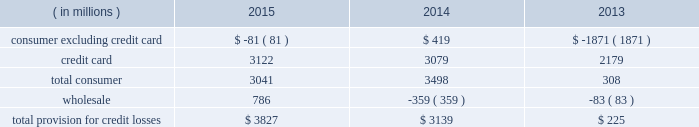Jpmorgan chase & co./2015 annual report 73 in advisory fees was driven by the combined impact of a greater share of fees for completed transactions , and growth in industry-wide fees .
The increase in equity underwriting fees was driven by higher industry-wide issuance .
The decrease in debt underwriting fees was primarily related to lower bond underwriting fees compared with the prior year , and lower loan syndication fees on lower industry-wide fees .
Principal transactions revenue increased as the prior year included a $ 1.5 billion loss related to the implementation of the funding valuation adjustment ( 201cfva 201d ) framework for over-the-counter ( 201cotc 201d ) derivatives and structured notes .
Private equity gains increased as a result of higher net gains on sales .
These increases were partially offset by lower fixed income markets revenue in cib , primarily driven by credit-related and rates products , as well as the impact of business simplification initiatives .
Lending- and deposit-related fees decreased compared with the prior year , reflecting the impact of business simplification initiatives and lower trade finance revenue in cib .
Asset management , administration and commissions revenue increased compared with the prior year , reflecting higher asset management fees driven by net client inflows and higher market levels in am and ccb .
The increase was offset partially by lower commissions and other fee revenue in ccb as a result of the exit of a non-core product in 2013 .
Securities gains decreased compared with the prior year , reflecting lower repositioning activity related to the firm 2019s investment securities portfolio .
Mortgage fees and related income decreased compared with the prior year , predominantly due to lower net production revenue driven by lower volumes due to higher mortgage interest rates , and tighter margins .
The decline in net production revenue was partially offset by a lower loss on the risk management of mortgage servicing rights ( 201cmsrs 201d ) .
Card income was relatively flat compared with the prior year , but included higher net interchange income due to growth in credit and debit card sales volume , offset by higher amortization of new account origination costs .
Other income decreased from the prior year , predominantly from the absence of two significant items recorded in corporate in 2013 : gains of $ 1.3 billion and $ 493 million from sales of visa shares and one chase manhattan plaza , respectively .
Lower valuations of seed capital investments in am and losses related to the exit of non-core portfolios in card also contributed to the decrease .
These items were partially offset by higher auto lease income as a result of growth in auto lease volume , and a benefit from a tax settlement .
Net interest income increased slightly from the prior year , predominantly reflecting higher yields on investment securities , the impact of lower interest expense from lower rates , and higher average loan balances .
The increase was partially offset by lower yields on loans due to the run-off of higher-yielding loans and new originations of lower-yielding loans , and lower average interest-earning trading asset balances .
The firm 2019s average interest-earning assets were $ 2.0 trillion , and the net interest yield on these assets , on a fte basis , was 2.18% ( 2.18 % ) , a decrease of 5 basis points from the prior year .
Provision for credit losses year ended december 31 .
2015 compared with 2014 the provision for credit losses increased from the prior year as a result of an increase in the wholesale provision , largely reflecting the impact of downgrades in the oil & gas portfolio .
The increase was partially offset by a decrease in the consumer provision , reflecting lower net charge-offs due to continued discipline in credit underwriting , as well as improvement in the economy driven by increasing home prices and lower unemployment levels .
The increase was partially offset by a lower reduction in the allowance for loan losses .
For a more detailed discussion of the credit portfolio and the allowance for credit losses , see the segment discussions of ccb on pages 85 201393 , cb on pages 99 2013101 , and the allowance for credit losses on pages 130 2013132 .
2014 compared with 2013 the provision for credit losses increased by $ 2.9 billion from the prior year as result of a lower benefit from reductions in the consumer allowance for loan losses , partially offset by lower net charge-offs .
The consumer allowance reduction in 2014 was primarily related to the consumer , excluding credit card , portfolio and reflected the continued improvement in home prices and delinquencies in the residential real estate portfolio .
The wholesale provision reflected a continued favorable credit environment. .
How much of the provision was for non-consumer credit losses? 
Computations: (786 / 3827)
Answer: 0.20538. Jpmorgan chase & co./2015 annual report 73 in advisory fees was driven by the combined impact of a greater share of fees for completed transactions , and growth in industry-wide fees .
The increase in equity underwriting fees was driven by higher industry-wide issuance .
The decrease in debt underwriting fees was primarily related to lower bond underwriting fees compared with the prior year , and lower loan syndication fees on lower industry-wide fees .
Principal transactions revenue increased as the prior year included a $ 1.5 billion loss related to the implementation of the funding valuation adjustment ( 201cfva 201d ) framework for over-the-counter ( 201cotc 201d ) derivatives and structured notes .
Private equity gains increased as a result of higher net gains on sales .
These increases were partially offset by lower fixed income markets revenue in cib , primarily driven by credit-related and rates products , as well as the impact of business simplification initiatives .
Lending- and deposit-related fees decreased compared with the prior year , reflecting the impact of business simplification initiatives and lower trade finance revenue in cib .
Asset management , administration and commissions revenue increased compared with the prior year , reflecting higher asset management fees driven by net client inflows and higher market levels in am and ccb .
The increase was offset partially by lower commissions and other fee revenue in ccb as a result of the exit of a non-core product in 2013 .
Securities gains decreased compared with the prior year , reflecting lower repositioning activity related to the firm 2019s investment securities portfolio .
Mortgage fees and related income decreased compared with the prior year , predominantly due to lower net production revenue driven by lower volumes due to higher mortgage interest rates , and tighter margins .
The decline in net production revenue was partially offset by a lower loss on the risk management of mortgage servicing rights ( 201cmsrs 201d ) .
Card income was relatively flat compared with the prior year , but included higher net interchange income due to growth in credit and debit card sales volume , offset by higher amortization of new account origination costs .
Other income decreased from the prior year , predominantly from the absence of two significant items recorded in corporate in 2013 : gains of $ 1.3 billion and $ 493 million from sales of visa shares and one chase manhattan plaza , respectively .
Lower valuations of seed capital investments in am and losses related to the exit of non-core portfolios in card also contributed to the decrease .
These items were partially offset by higher auto lease income as a result of growth in auto lease volume , and a benefit from a tax settlement .
Net interest income increased slightly from the prior year , predominantly reflecting higher yields on investment securities , the impact of lower interest expense from lower rates , and higher average loan balances .
The increase was partially offset by lower yields on loans due to the run-off of higher-yielding loans and new originations of lower-yielding loans , and lower average interest-earning trading asset balances .
The firm 2019s average interest-earning assets were $ 2.0 trillion , and the net interest yield on these assets , on a fte basis , was 2.18% ( 2.18 % ) , a decrease of 5 basis points from the prior year .
Provision for credit losses year ended december 31 .
2015 compared with 2014 the provision for credit losses increased from the prior year as a result of an increase in the wholesale provision , largely reflecting the impact of downgrades in the oil & gas portfolio .
The increase was partially offset by a decrease in the consumer provision , reflecting lower net charge-offs due to continued discipline in credit underwriting , as well as improvement in the economy driven by increasing home prices and lower unemployment levels .
The increase was partially offset by a lower reduction in the allowance for loan losses .
For a more detailed discussion of the credit portfolio and the allowance for credit losses , see the segment discussions of ccb on pages 85 201393 , cb on pages 99 2013101 , and the allowance for credit losses on pages 130 2013132 .
2014 compared with 2013 the provision for credit losses increased by $ 2.9 billion from the prior year as result of a lower benefit from reductions in the consumer allowance for loan losses , partially offset by lower net charge-offs .
The consumer allowance reduction in 2014 was primarily related to the consumer , excluding credit card , portfolio and reflected the continued improvement in home prices and delinquencies in the residential real estate portfolio .
The wholesale provision reflected a continued favorable credit environment. .
In 2015 what was the percent of the credit card as part of the total provision for credit losses? 
Computations: (3122 / 3827)
Answer: 0.81578. 